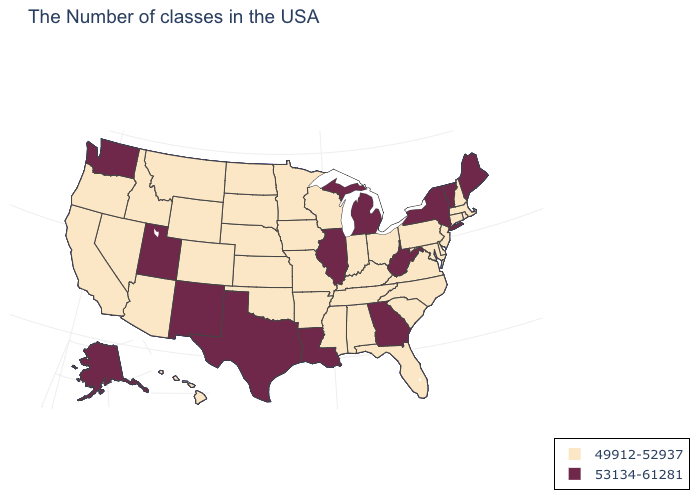Does the map have missing data?
Give a very brief answer. No. What is the value of Rhode Island?
Keep it brief. 49912-52937. Among the states that border Ohio , which have the highest value?
Short answer required. West Virginia, Michigan. Does North Carolina have the highest value in the South?
Be succinct. No. Name the states that have a value in the range 49912-52937?
Answer briefly. Massachusetts, Rhode Island, New Hampshire, Connecticut, New Jersey, Delaware, Maryland, Pennsylvania, Virginia, North Carolina, South Carolina, Ohio, Florida, Kentucky, Indiana, Alabama, Tennessee, Wisconsin, Mississippi, Missouri, Arkansas, Minnesota, Iowa, Kansas, Nebraska, Oklahoma, South Dakota, North Dakota, Wyoming, Colorado, Montana, Arizona, Idaho, Nevada, California, Oregon, Hawaii. Does Connecticut have the same value as Delaware?
Quick response, please. Yes. What is the value of California?
Quick response, please. 49912-52937. What is the highest value in states that border Oregon?
Short answer required. 53134-61281. What is the value of Alabama?
Keep it brief. 49912-52937. Name the states that have a value in the range 53134-61281?
Quick response, please. Maine, Vermont, New York, West Virginia, Georgia, Michigan, Illinois, Louisiana, Texas, New Mexico, Utah, Washington, Alaska. What is the lowest value in states that border Tennessee?
Answer briefly. 49912-52937. Which states have the highest value in the USA?
Quick response, please. Maine, Vermont, New York, West Virginia, Georgia, Michigan, Illinois, Louisiana, Texas, New Mexico, Utah, Washington, Alaska. How many symbols are there in the legend?
Quick response, please. 2. Name the states that have a value in the range 49912-52937?
Keep it brief. Massachusetts, Rhode Island, New Hampshire, Connecticut, New Jersey, Delaware, Maryland, Pennsylvania, Virginia, North Carolina, South Carolina, Ohio, Florida, Kentucky, Indiana, Alabama, Tennessee, Wisconsin, Mississippi, Missouri, Arkansas, Minnesota, Iowa, Kansas, Nebraska, Oklahoma, South Dakota, North Dakota, Wyoming, Colorado, Montana, Arizona, Idaho, Nevada, California, Oregon, Hawaii. What is the value of Nevada?
Answer briefly. 49912-52937. 